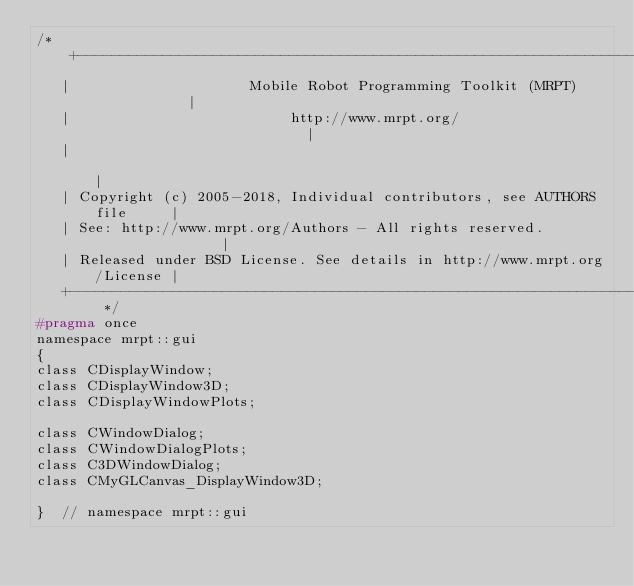<code> <loc_0><loc_0><loc_500><loc_500><_C_>/* +------------------------------------------------------------------------+
   |                     Mobile Robot Programming Toolkit (MRPT)            |
   |                          http://www.mrpt.org/                          |
   |                                                                        |
   | Copyright (c) 2005-2018, Individual contributors, see AUTHORS file     |
   | See: http://www.mrpt.org/Authors - All rights reserved.                |
   | Released under BSD License. See details in http://www.mrpt.org/License |
   +------------------------------------------------------------------------+ */
#pragma once
namespace mrpt::gui
{
class CDisplayWindow;
class CDisplayWindow3D;
class CDisplayWindowPlots;

class CWindowDialog;
class CWindowDialogPlots;
class C3DWindowDialog;
class CMyGLCanvas_DisplayWindow3D;

}  // namespace mrpt::gui
</code> 